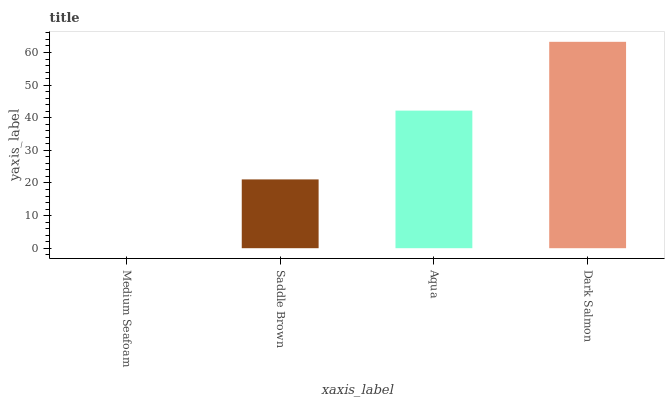Is Saddle Brown the minimum?
Answer yes or no. No. Is Saddle Brown the maximum?
Answer yes or no. No. Is Saddle Brown greater than Medium Seafoam?
Answer yes or no. Yes. Is Medium Seafoam less than Saddle Brown?
Answer yes or no. Yes. Is Medium Seafoam greater than Saddle Brown?
Answer yes or no. No. Is Saddle Brown less than Medium Seafoam?
Answer yes or no. No. Is Aqua the high median?
Answer yes or no. Yes. Is Saddle Brown the low median?
Answer yes or no. Yes. Is Saddle Brown the high median?
Answer yes or no. No. Is Medium Seafoam the low median?
Answer yes or no. No. 